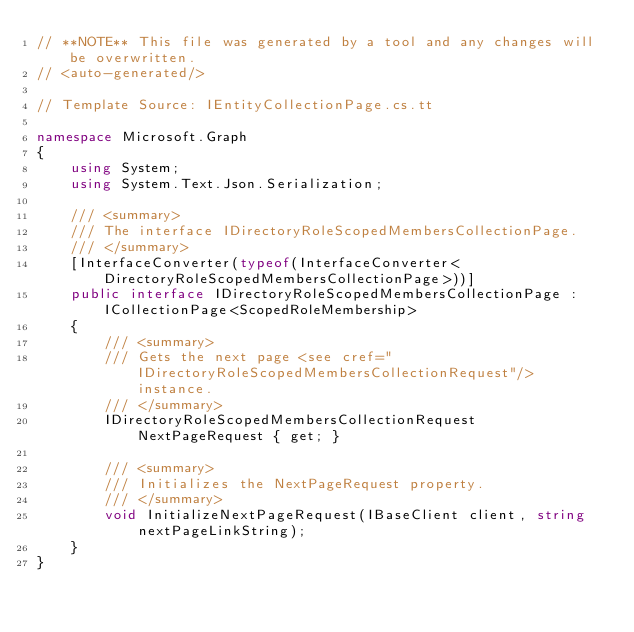<code> <loc_0><loc_0><loc_500><loc_500><_C#_>// **NOTE** This file was generated by a tool and any changes will be overwritten.
// <auto-generated/>

// Template Source: IEntityCollectionPage.cs.tt

namespace Microsoft.Graph
{
    using System;
    using System.Text.Json.Serialization;

    /// <summary>
    /// The interface IDirectoryRoleScopedMembersCollectionPage.
    /// </summary>
    [InterfaceConverter(typeof(InterfaceConverter<DirectoryRoleScopedMembersCollectionPage>))]
    public interface IDirectoryRoleScopedMembersCollectionPage : ICollectionPage<ScopedRoleMembership>
    {
        /// <summary>
        /// Gets the next page <see cref="IDirectoryRoleScopedMembersCollectionRequest"/> instance.
        /// </summary>
        IDirectoryRoleScopedMembersCollectionRequest NextPageRequest { get; }

        /// <summary>
        /// Initializes the NextPageRequest property.
        /// </summary>
        void InitializeNextPageRequest(IBaseClient client, string nextPageLinkString);
    }
}
</code> 